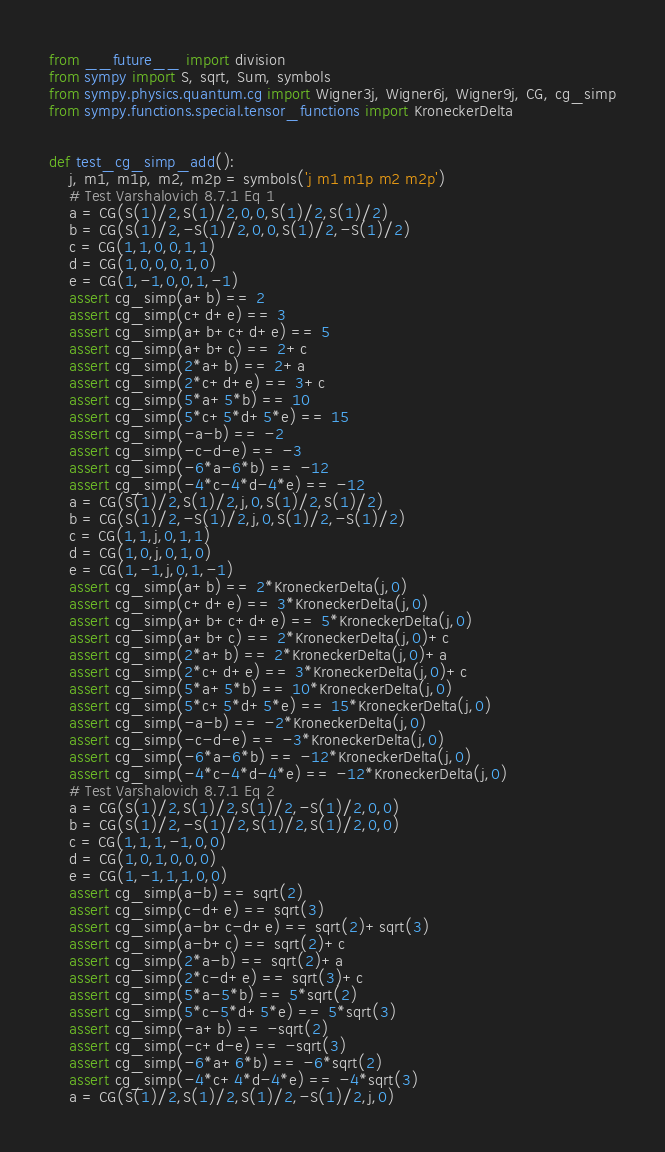Convert code to text. <code><loc_0><loc_0><loc_500><loc_500><_Python_>from __future__ import division
from sympy import S, sqrt, Sum, symbols
from sympy.physics.quantum.cg import Wigner3j, Wigner6j, Wigner9j, CG, cg_simp
from sympy.functions.special.tensor_functions import KroneckerDelta


def test_cg_simp_add():
    j, m1, m1p, m2, m2p = symbols('j m1 m1p m2 m2p')
    # Test Varshalovich 8.7.1 Eq 1
    a = CG(S(1)/2,S(1)/2,0,0,S(1)/2,S(1)/2)
    b = CG(S(1)/2,-S(1)/2,0,0,S(1)/2,-S(1)/2)
    c = CG(1,1,0,0,1,1)
    d = CG(1,0,0,0,1,0)
    e = CG(1,-1,0,0,1,-1)
    assert cg_simp(a+b) == 2
    assert cg_simp(c+d+e) == 3
    assert cg_simp(a+b+c+d+e) == 5
    assert cg_simp(a+b+c) == 2+c
    assert cg_simp(2*a+b) == 2+a
    assert cg_simp(2*c+d+e) == 3+c
    assert cg_simp(5*a+5*b) == 10
    assert cg_simp(5*c+5*d+5*e) == 15
    assert cg_simp(-a-b) == -2
    assert cg_simp(-c-d-e) == -3
    assert cg_simp(-6*a-6*b) == -12
    assert cg_simp(-4*c-4*d-4*e) == -12
    a = CG(S(1)/2,S(1)/2,j,0,S(1)/2,S(1)/2)
    b = CG(S(1)/2,-S(1)/2,j,0,S(1)/2,-S(1)/2)
    c = CG(1,1,j,0,1,1)
    d = CG(1,0,j,0,1,0)
    e = CG(1,-1,j,0,1,-1)
    assert cg_simp(a+b) == 2*KroneckerDelta(j,0)
    assert cg_simp(c+d+e) == 3*KroneckerDelta(j,0)
    assert cg_simp(a+b+c+d+e) == 5*KroneckerDelta(j,0)
    assert cg_simp(a+b+c) == 2*KroneckerDelta(j,0)+c
    assert cg_simp(2*a+b) == 2*KroneckerDelta(j,0)+a
    assert cg_simp(2*c+d+e) == 3*KroneckerDelta(j,0)+c
    assert cg_simp(5*a+5*b) == 10*KroneckerDelta(j,0)
    assert cg_simp(5*c+5*d+5*e) == 15*KroneckerDelta(j,0)
    assert cg_simp(-a-b) == -2*KroneckerDelta(j,0)
    assert cg_simp(-c-d-e) == -3*KroneckerDelta(j,0)
    assert cg_simp(-6*a-6*b) == -12*KroneckerDelta(j,0)
    assert cg_simp(-4*c-4*d-4*e) == -12*KroneckerDelta(j,0)
    # Test Varshalovich 8.7.1 Eq 2
    a = CG(S(1)/2,S(1)/2,S(1)/2,-S(1)/2,0,0)
    b = CG(S(1)/2,-S(1)/2,S(1)/2,S(1)/2,0,0)
    c = CG(1,1,1,-1,0,0)
    d = CG(1,0,1,0,0,0)
    e = CG(1,-1,1,1,0,0)
    assert cg_simp(a-b) == sqrt(2)
    assert cg_simp(c-d+e) == sqrt(3)
    assert cg_simp(a-b+c-d+e) == sqrt(2)+sqrt(3)
    assert cg_simp(a-b+c) == sqrt(2)+c
    assert cg_simp(2*a-b) == sqrt(2)+a
    assert cg_simp(2*c-d+e) == sqrt(3)+c
    assert cg_simp(5*a-5*b) == 5*sqrt(2)
    assert cg_simp(5*c-5*d+5*e) == 5*sqrt(3)
    assert cg_simp(-a+b) == -sqrt(2)
    assert cg_simp(-c+d-e) == -sqrt(3)
    assert cg_simp(-6*a+6*b) == -6*sqrt(2)
    assert cg_simp(-4*c+4*d-4*e) == -4*sqrt(3)
    a = CG(S(1)/2,S(1)/2,S(1)/2,-S(1)/2,j,0)</code> 